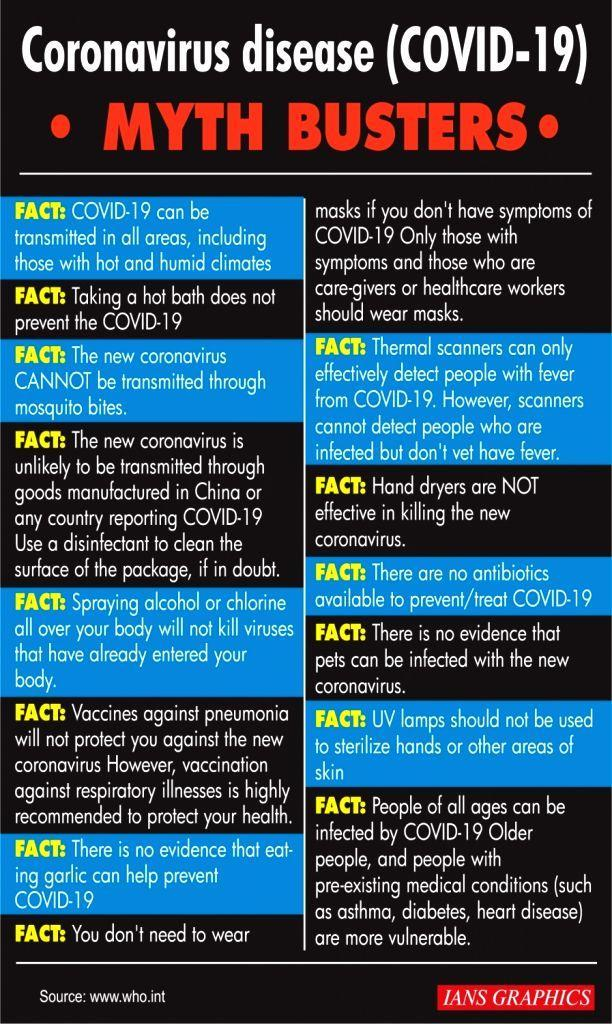How many facts about coronavirus disease are in this infographic?
Answer the question with a short phrase. 14 How many medical conditions are in this infographic? 3 